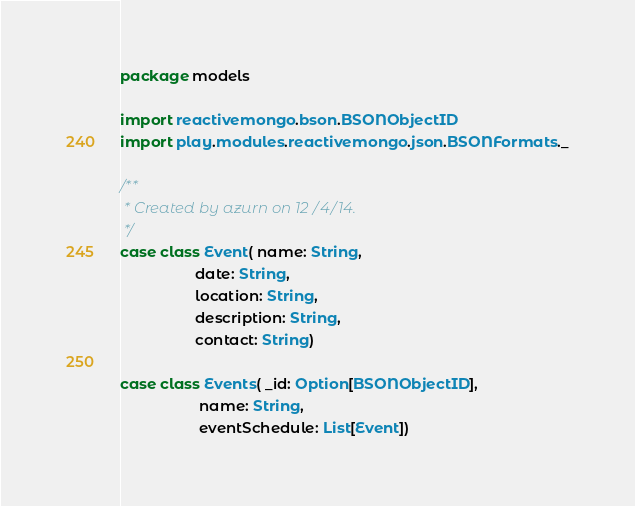<code> <loc_0><loc_0><loc_500><loc_500><_Scala_>package models

import reactivemongo.bson.BSONObjectID
import play.modules.reactivemongo.json.BSONFormats._

/**
 * Created by azurn on 12/4/14.
 */
case class Event( name: String,
                  date: String,
                  location: String,
                  description: String,
                  contact: String)

case class Events( _id: Option[BSONObjectID],
                   name: String,
                   eventSchedule: List[Event])
</code> 